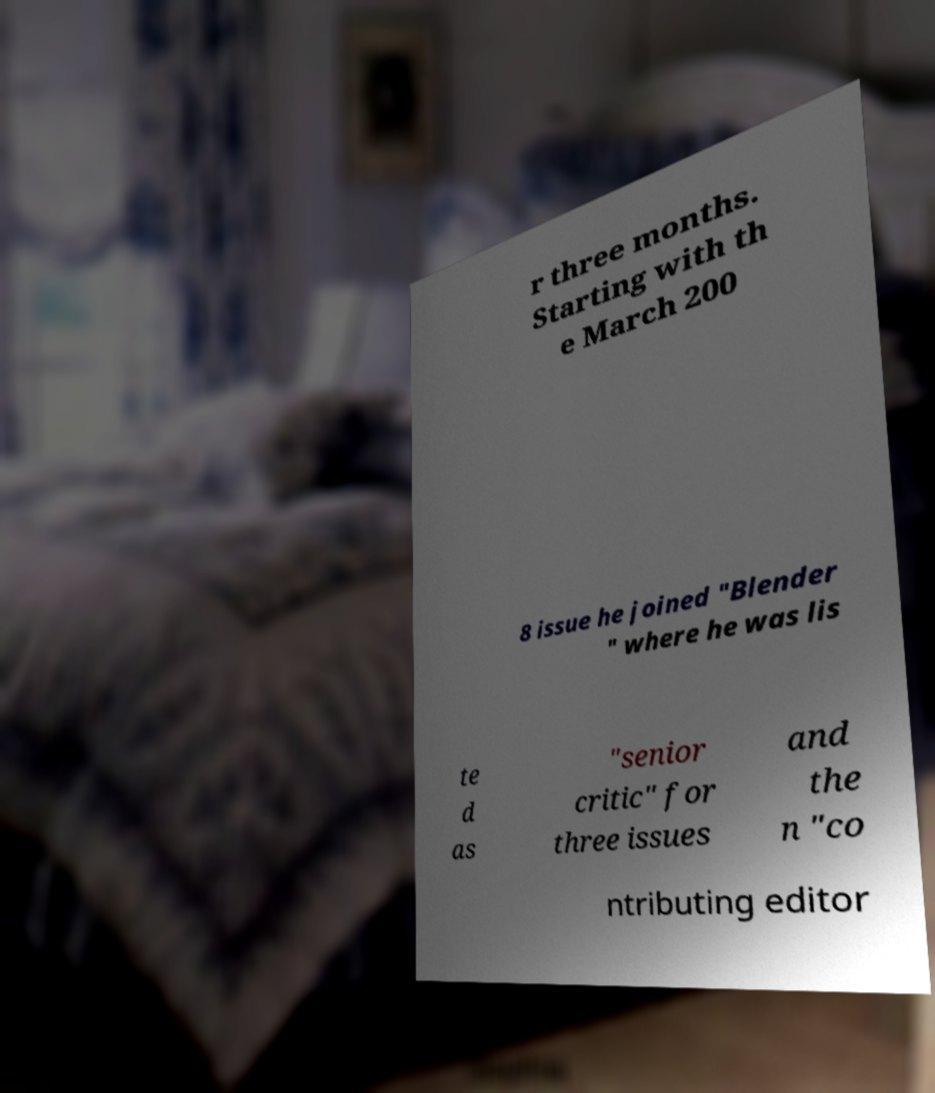Could you extract and type out the text from this image? r three months. Starting with th e March 200 8 issue he joined "Blender " where he was lis te d as "senior critic" for three issues and the n "co ntributing editor 